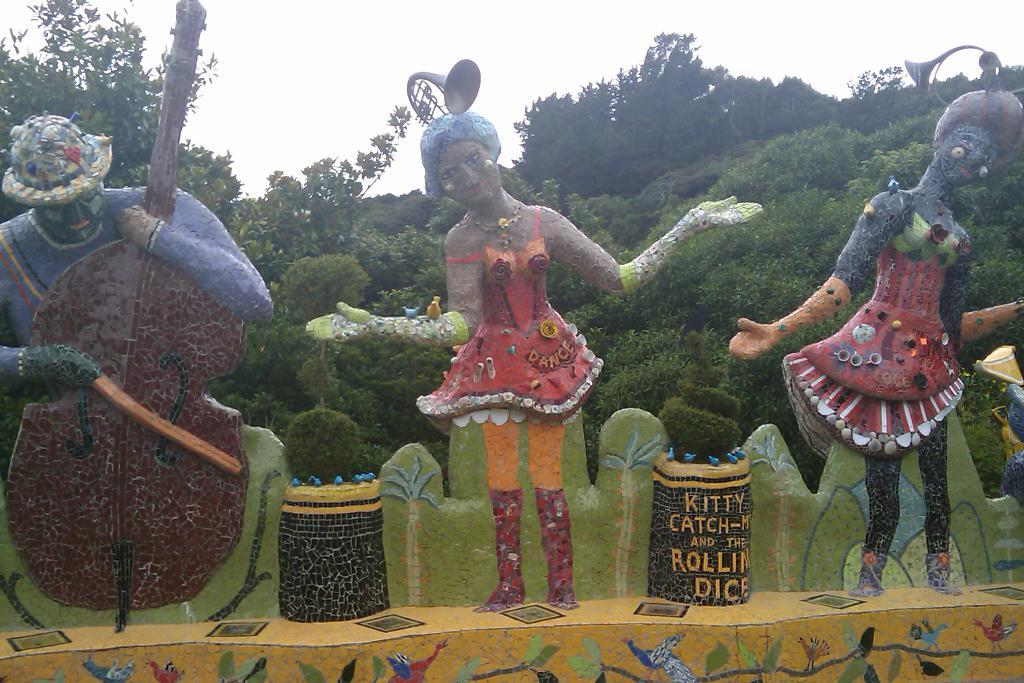What type of artwork can be seen in the image? There are sculptures and paintings in the image. What can be seen in the background of the image? There are plants, trees, and the sky visible in the background of the image. What type of animal can be seen sitting on the windowsill in the image? There is no animal or windowsill present in the image. 